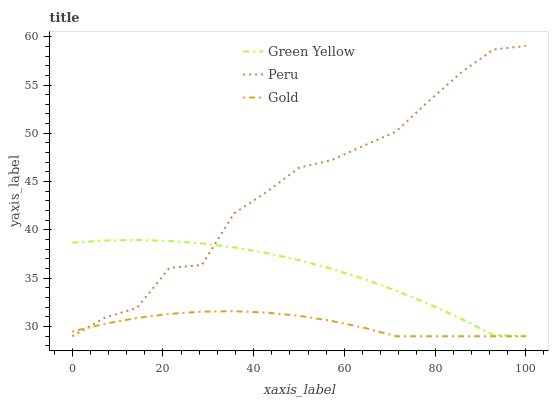Does Gold have the minimum area under the curve?
Answer yes or no. Yes. Does Peru have the maximum area under the curve?
Answer yes or no. Yes. Does Peru have the minimum area under the curve?
Answer yes or no. No. Does Gold have the maximum area under the curve?
Answer yes or no. No. Is Gold the smoothest?
Answer yes or no. Yes. Is Peru the roughest?
Answer yes or no. Yes. Is Peru the smoothest?
Answer yes or no. No. Is Gold the roughest?
Answer yes or no. No. Does Green Yellow have the lowest value?
Answer yes or no. Yes. Does Peru have the highest value?
Answer yes or no. Yes. Does Gold have the highest value?
Answer yes or no. No. Does Gold intersect Peru?
Answer yes or no. Yes. Is Gold less than Peru?
Answer yes or no. No. Is Gold greater than Peru?
Answer yes or no. No. 